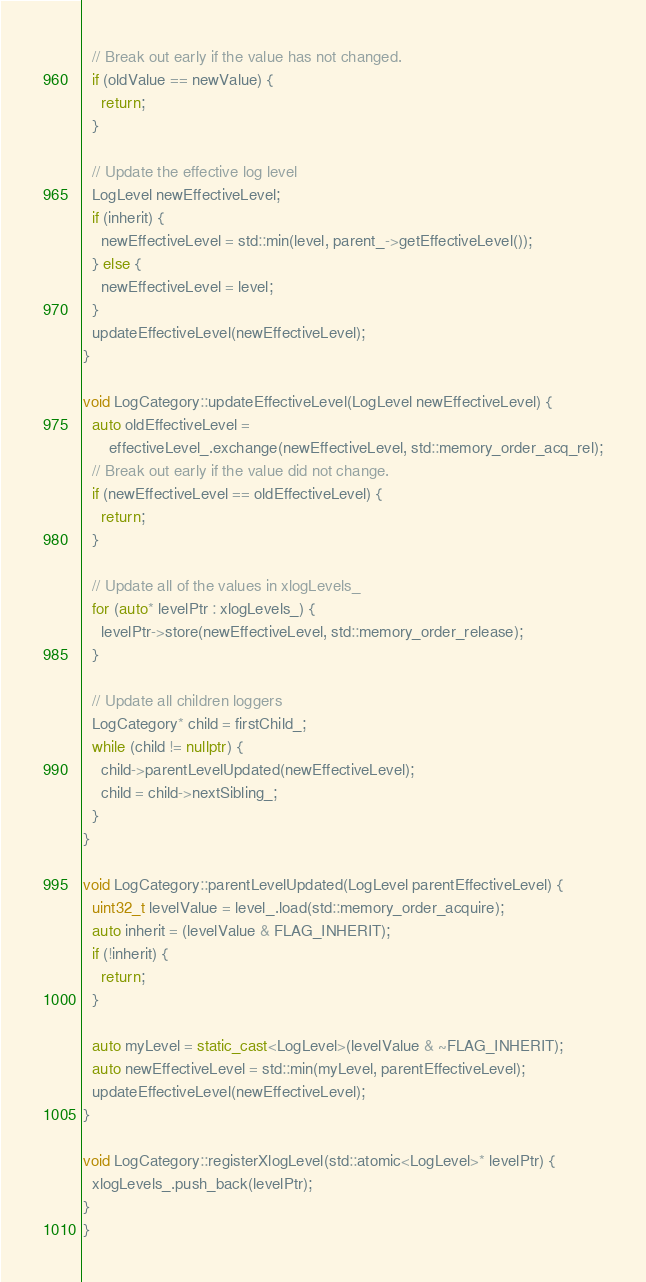Convert code to text. <code><loc_0><loc_0><loc_500><loc_500><_C++_>  // Break out early if the value has not changed.
  if (oldValue == newValue) {
    return;
  }

  // Update the effective log level
  LogLevel newEffectiveLevel;
  if (inherit) {
    newEffectiveLevel = std::min(level, parent_->getEffectiveLevel());
  } else {
    newEffectiveLevel = level;
  }
  updateEffectiveLevel(newEffectiveLevel);
}

void LogCategory::updateEffectiveLevel(LogLevel newEffectiveLevel) {
  auto oldEffectiveLevel =
      effectiveLevel_.exchange(newEffectiveLevel, std::memory_order_acq_rel);
  // Break out early if the value did not change.
  if (newEffectiveLevel == oldEffectiveLevel) {
    return;
  }

  // Update all of the values in xlogLevels_
  for (auto* levelPtr : xlogLevels_) {
    levelPtr->store(newEffectiveLevel, std::memory_order_release);
  }

  // Update all children loggers
  LogCategory* child = firstChild_;
  while (child != nullptr) {
    child->parentLevelUpdated(newEffectiveLevel);
    child = child->nextSibling_;
  }
}

void LogCategory::parentLevelUpdated(LogLevel parentEffectiveLevel) {
  uint32_t levelValue = level_.load(std::memory_order_acquire);
  auto inherit = (levelValue & FLAG_INHERIT);
  if (!inherit) {
    return;
  }

  auto myLevel = static_cast<LogLevel>(levelValue & ~FLAG_INHERIT);
  auto newEffectiveLevel = std::min(myLevel, parentEffectiveLevel);
  updateEffectiveLevel(newEffectiveLevel);
}

void LogCategory::registerXlogLevel(std::atomic<LogLevel>* levelPtr) {
  xlogLevels_.push_back(levelPtr);
}
}
</code> 